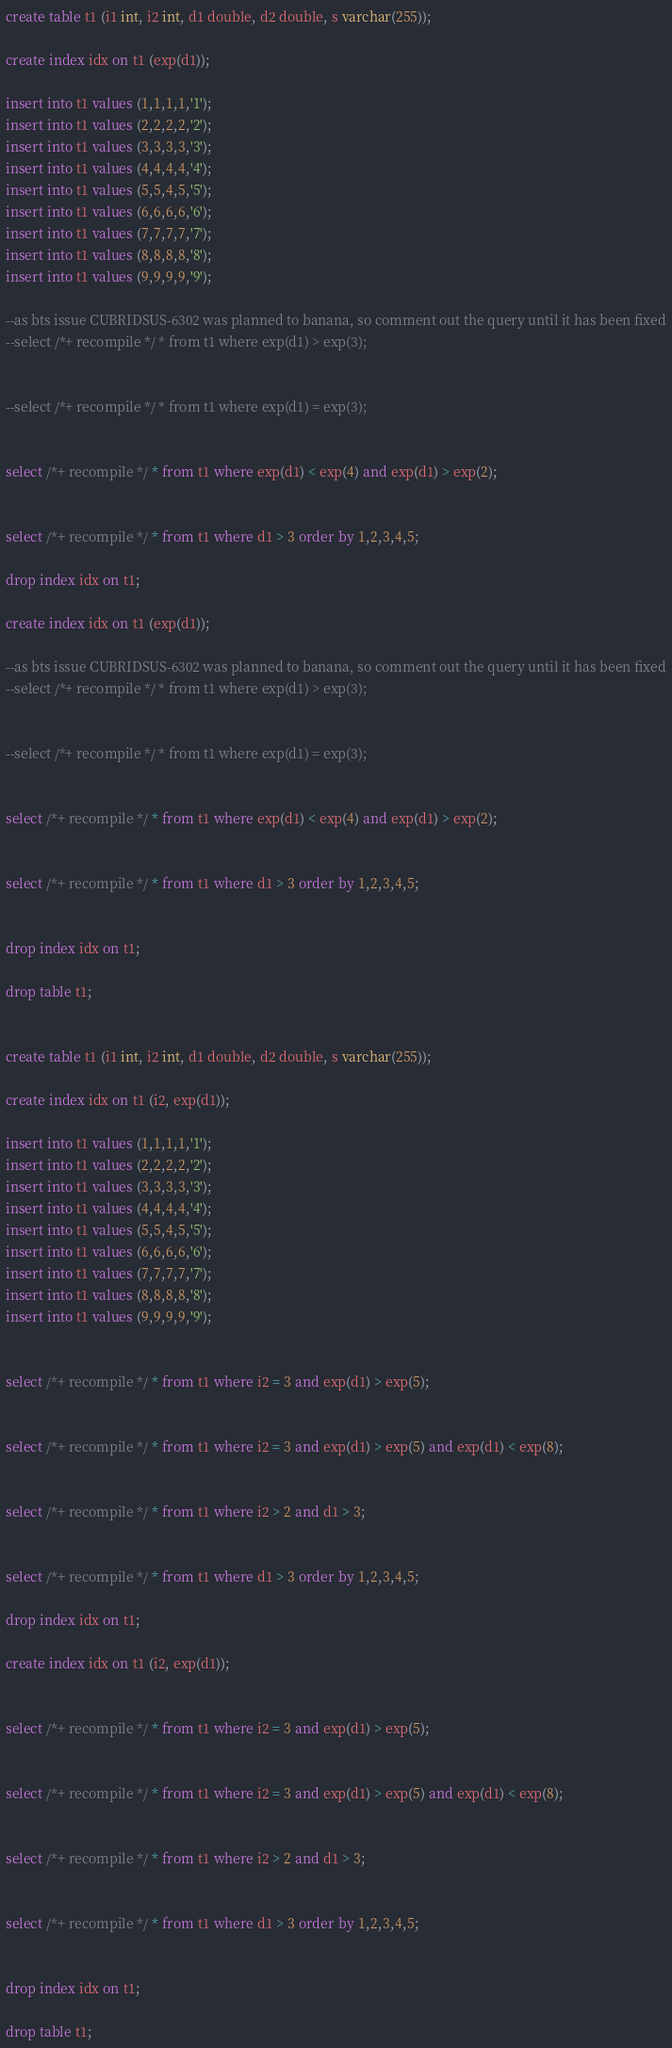Convert code to text. <code><loc_0><loc_0><loc_500><loc_500><_SQL_>create table t1 (i1 int, i2 int, d1 double, d2 double, s varchar(255));

create index idx on t1 (exp(d1));

insert into t1 values (1,1,1,1,'1');
insert into t1 values (2,2,2,2,'2');
insert into t1 values (3,3,3,3,'3');
insert into t1 values (4,4,4,4,'4');
insert into t1 values (5,5,4,5,'5');
insert into t1 values (6,6,6,6,'6');
insert into t1 values (7,7,7,7,'7');
insert into t1 values (8,8,8,8,'8');
insert into t1 values (9,9,9,9,'9');

--as bts issue CUBRIDSUS-6302 was planned to banana, so comment out the query until it has been fixed
--select /*+ recompile */ * from t1 where exp(d1) > exp(3);


--select /*+ recompile */ * from t1 where exp(d1) = exp(3);


select /*+ recompile */ * from t1 where exp(d1) < exp(4) and exp(d1) > exp(2);


select /*+ recompile */ * from t1 where d1 > 3 order by 1,2,3,4,5;

drop index idx on t1;

create index idx on t1 (exp(d1));

--as bts issue CUBRIDSUS-6302 was planned to banana, so comment out the query until it has been fixed
--select /*+ recompile */ * from t1 where exp(d1) > exp(3);


--select /*+ recompile */ * from t1 where exp(d1) = exp(3);


select /*+ recompile */ * from t1 where exp(d1) < exp(4) and exp(d1) > exp(2);


select /*+ recompile */ * from t1 where d1 > 3 order by 1,2,3,4,5;


drop index idx on t1;

drop table t1;


create table t1 (i1 int, i2 int, d1 double, d2 double, s varchar(255));

create index idx on t1 (i2, exp(d1));

insert into t1 values (1,1,1,1,'1');
insert into t1 values (2,2,2,2,'2');
insert into t1 values (3,3,3,3,'3');
insert into t1 values (4,4,4,4,'4');
insert into t1 values (5,5,4,5,'5');
insert into t1 values (6,6,6,6,'6');
insert into t1 values (7,7,7,7,'7');
insert into t1 values (8,8,8,8,'8');
insert into t1 values (9,9,9,9,'9');


select /*+ recompile */ * from t1 where i2 = 3 and exp(d1) > exp(5);


select /*+ recompile */ * from t1 where i2 = 3 and exp(d1) > exp(5) and exp(d1) < exp(8);


select /*+ recompile */ * from t1 where i2 > 2 and d1 > 3;


select /*+ recompile */ * from t1 where d1 > 3 order by 1,2,3,4,5;

drop index idx on t1;

create index idx on t1 (i2, exp(d1));


select /*+ recompile */ * from t1 where i2 = 3 and exp(d1) > exp(5);


select /*+ recompile */ * from t1 where i2 = 3 and exp(d1) > exp(5) and exp(d1) < exp(8);


select /*+ recompile */ * from t1 where i2 > 2 and d1 > 3;


select /*+ recompile */ * from t1 where d1 > 3 order by 1,2,3,4,5;


drop index idx on t1;

drop table t1;

</code> 